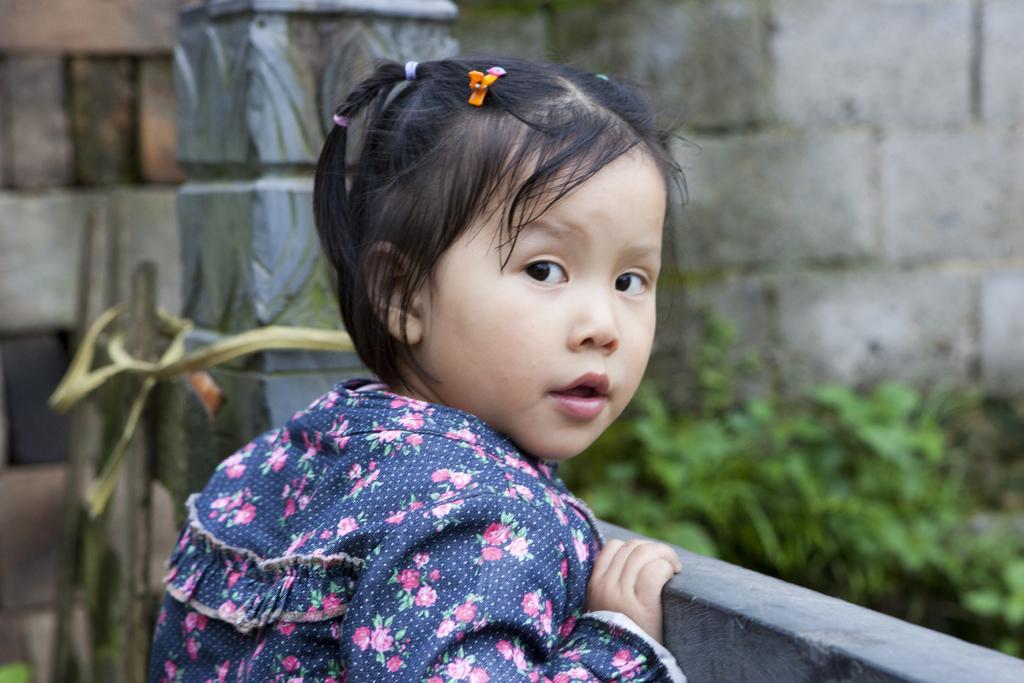Could you give a brief overview of what you see in this image? Here we can see a girl. Background we can see wall and plants. 